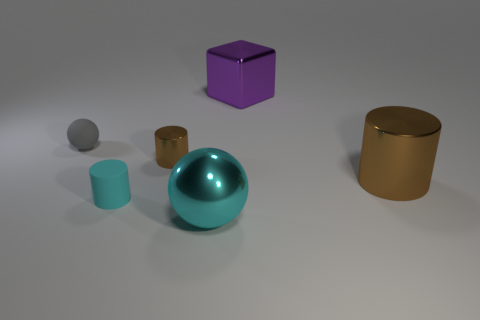What time of day does the lighting suggest, and what might that say about the setting? The lighting in the image seems artificial, distancing it from a specific time of day. It is soft and diffused, suggesting an interior setting, maybe within a studio or controlled environment designed for object rendering. The lack of harsh shadows and the balanced illumination aim to reduce reflection and reveal the true colors and textures of each object, which is typically preferred in product photography or in the creation of visual assets for digital media. 